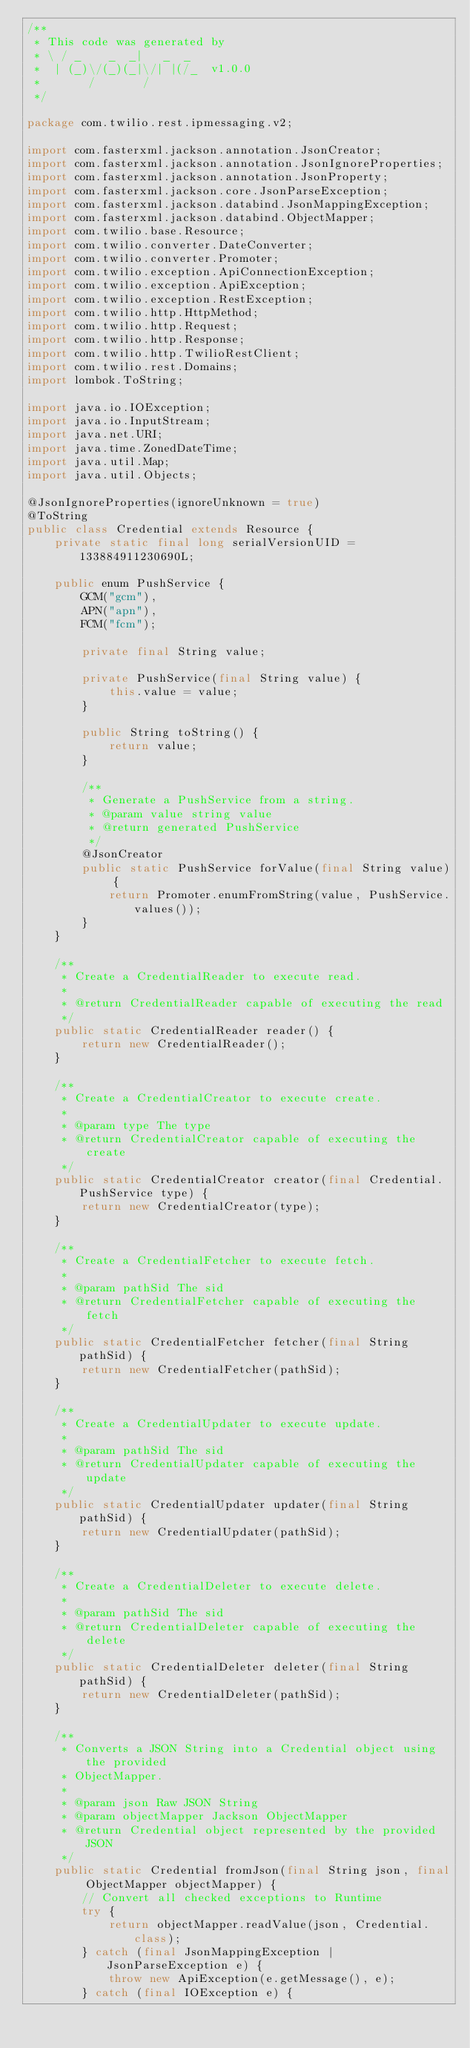Convert code to text. <code><loc_0><loc_0><loc_500><loc_500><_Java_>/**
 * This code was generated by
 * \ / _    _  _|   _  _
 *  | (_)\/(_)(_|\/| |(/_  v1.0.0
 *       /       /
 */

package com.twilio.rest.ipmessaging.v2;

import com.fasterxml.jackson.annotation.JsonCreator;
import com.fasterxml.jackson.annotation.JsonIgnoreProperties;
import com.fasterxml.jackson.annotation.JsonProperty;
import com.fasterxml.jackson.core.JsonParseException;
import com.fasterxml.jackson.databind.JsonMappingException;
import com.fasterxml.jackson.databind.ObjectMapper;
import com.twilio.base.Resource;
import com.twilio.converter.DateConverter;
import com.twilio.converter.Promoter;
import com.twilio.exception.ApiConnectionException;
import com.twilio.exception.ApiException;
import com.twilio.exception.RestException;
import com.twilio.http.HttpMethod;
import com.twilio.http.Request;
import com.twilio.http.Response;
import com.twilio.http.TwilioRestClient;
import com.twilio.rest.Domains;
import lombok.ToString;

import java.io.IOException;
import java.io.InputStream;
import java.net.URI;
import java.time.ZonedDateTime;
import java.util.Map;
import java.util.Objects;

@JsonIgnoreProperties(ignoreUnknown = true)
@ToString
public class Credential extends Resource {
    private static final long serialVersionUID = 133884911230690L;

    public enum PushService {
        GCM("gcm"),
        APN("apn"),
        FCM("fcm");

        private final String value;

        private PushService(final String value) {
            this.value = value;
        }

        public String toString() {
            return value;
        }

        /**
         * Generate a PushService from a string.
         * @param value string value
         * @return generated PushService
         */
        @JsonCreator
        public static PushService forValue(final String value) {
            return Promoter.enumFromString(value, PushService.values());
        }
    }

    /**
     * Create a CredentialReader to execute read.
     *
     * @return CredentialReader capable of executing the read
     */
    public static CredentialReader reader() {
        return new CredentialReader();
    }

    /**
     * Create a CredentialCreator to execute create.
     *
     * @param type The type
     * @return CredentialCreator capable of executing the create
     */
    public static CredentialCreator creator(final Credential.PushService type) {
        return new CredentialCreator(type);
    }

    /**
     * Create a CredentialFetcher to execute fetch.
     *
     * @param pathSid The sid
     * @return CredentialFetcher capable of executing the fetch
     */
    public static CredentialFetcher fetcher(final String pathSid) {
        return new CredentialFetcher(pathSid);
    }

    /**
     * Create a CredentialUpdater to execute update.
     *
     * @param pathSid The sid
     * @return CredentialUpdater capable of executing the update
     */
    public static CredentialUpdater updater(final String pathSid) {
        return new CredentialUpdater(pathSid);
    }

    /**
     * Create a CredentialDeleter to execute delete.
     *
     * @param pathSid The sid
     * @return CredentialDeleter capable of executing the delete
     */
    public static CredentialDeleter deleter(final String pathSid) {
        return new CredentialDeleter(pathSid);
    }

    /**
     * Converts a JSON String into a Credential object using the provided
     * ObjectMapper.
     *
     * @param json Raw JSON String
     * @param objectMapper Jackson ObjectMapper
     * @return Credential object represented by the provided JSON
     */
    public static Credential fromJson(final String json, final ObjectMapper objectMapper) {
        // Convert all checked exceptions to Runtime
        try {
            return objectMapper.readValue(json, Credential.class);
        } catch (final JsonMappingException | JsonParseException e) {
            throw new ApiException(e.getMessage(), e);
        } catch (final IOException e) {</code> 